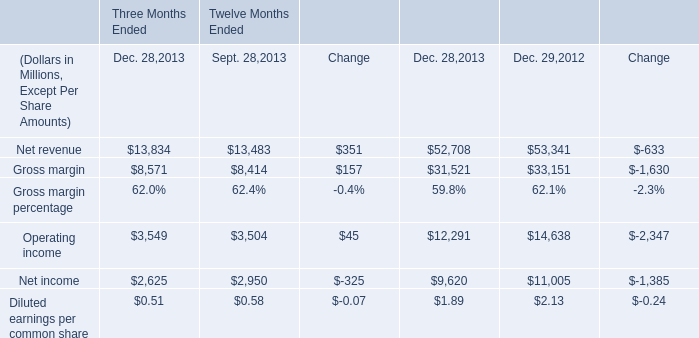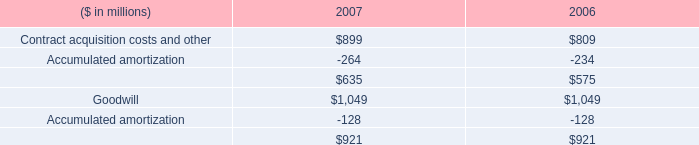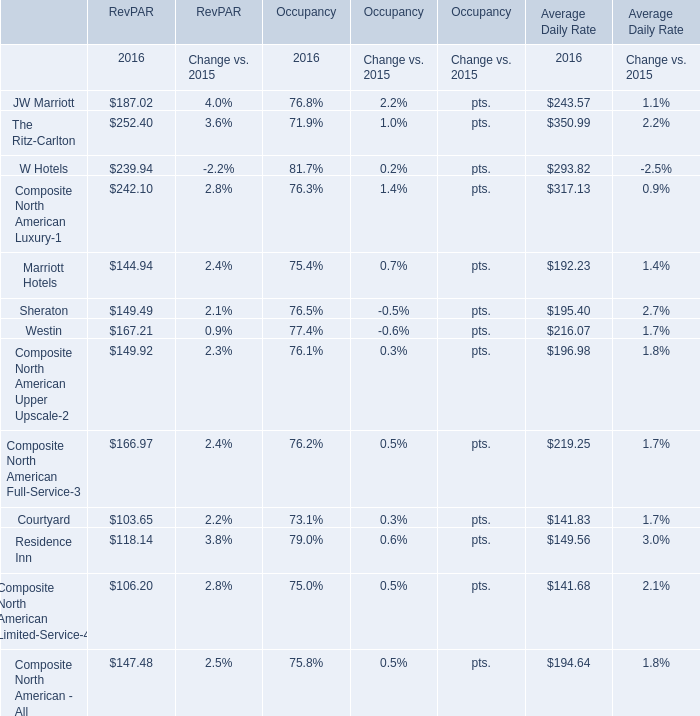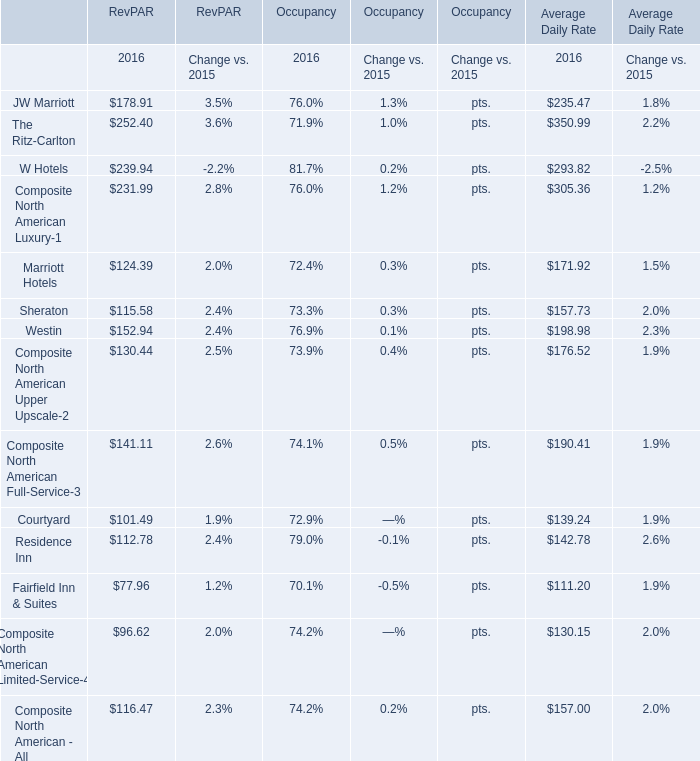What is the sum of RevPAR for Courtyard in 2016? 
Answer: 101.49. 